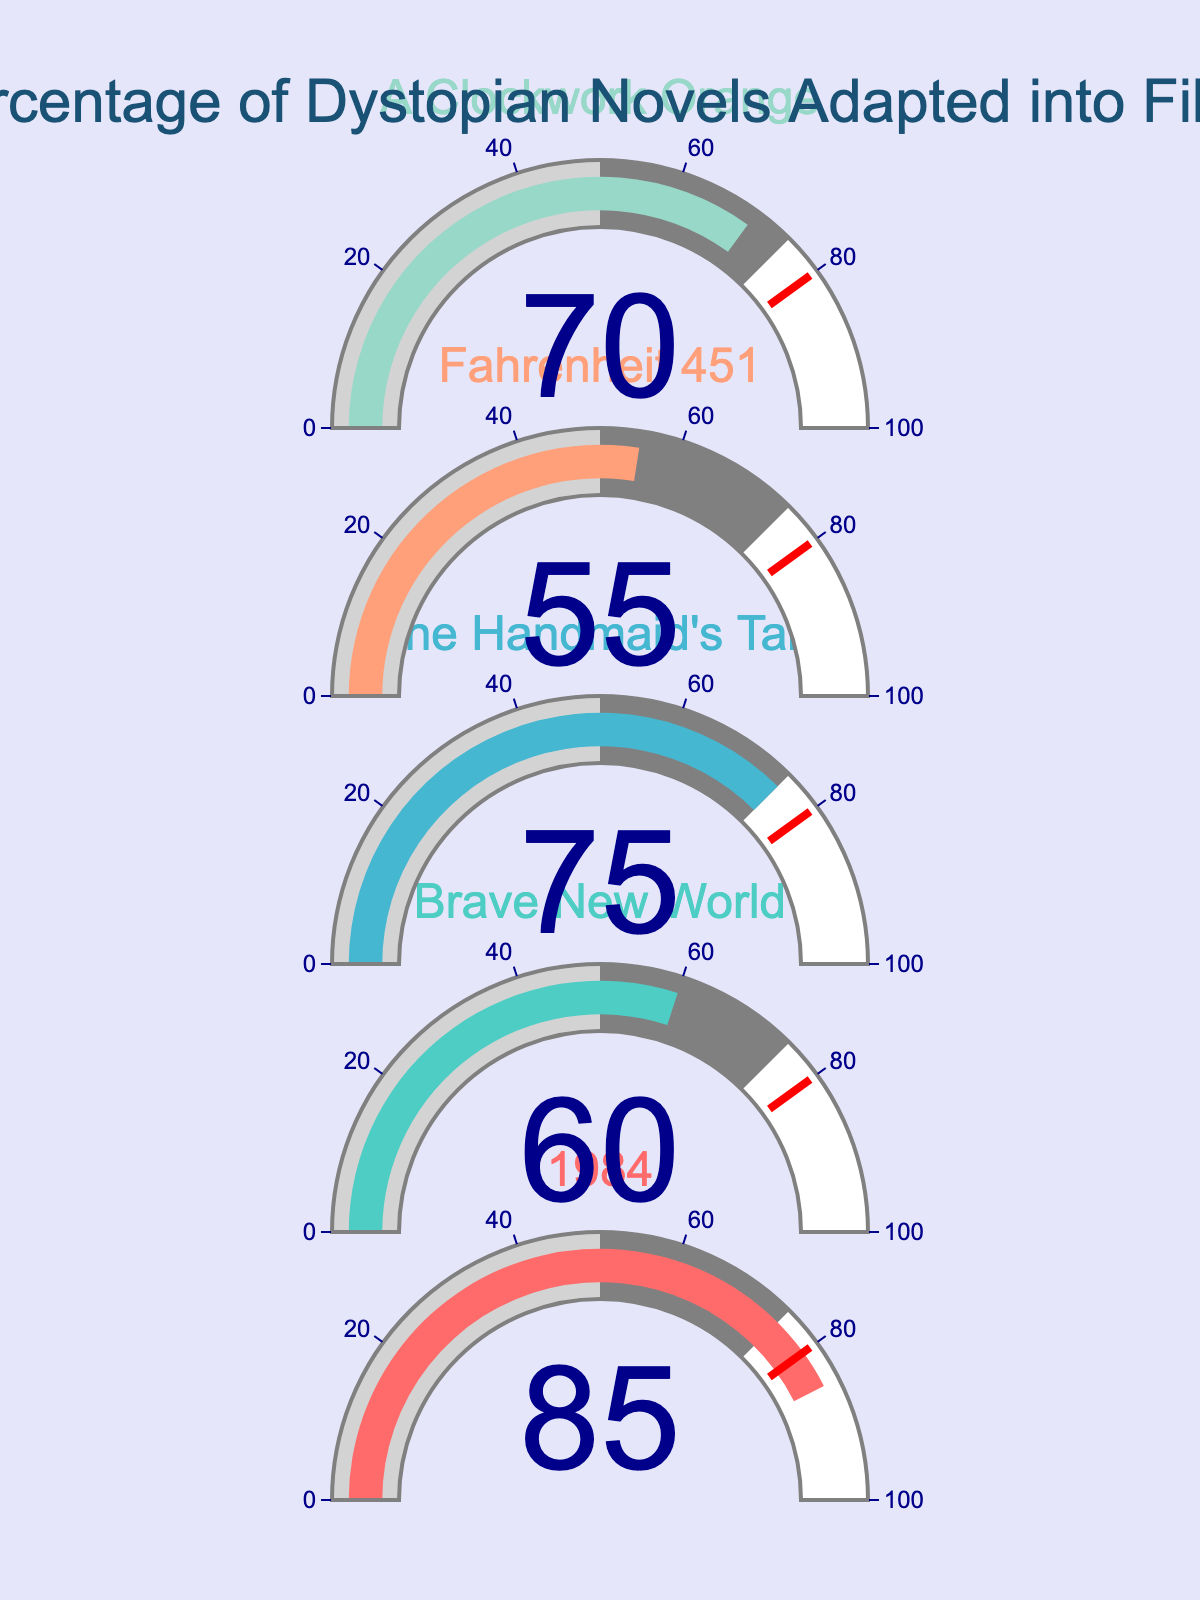Which dystopian novel has the highest adaptation percentage? The gauge chart shows the adaptation percentages for various dystopian novels. By comparing the values shown on the gauges, we see that "1984" has the highest adaptation percentage at 85%.
Answer: 1984 Which dystopian novel has the lowest adaptation percentage? The gauges display the adaptation percentages of different novels. The lowest value on the gauges is 55%, which corresponds to "Fahrenheit 451".
Answer: Fahrenheit 451 What is the average adaptation percentage of all the dystopian novels? To find the average adaptation percentage, add the percentages and divide by the number of novels: (85 + 60 + 75 + 55 + 70) / 5 = 345 / 5 = 69.
Answer: 69 Which two dystopian novels have adaptation percentages closest to each other? Checking the gauges, we see that "Brave New World" has an adaptation percentage of 60%, and "Fahrenheit 451" has an adaptation percentage of 55%. The difference between these two values is the smallest.
Answer: Brave New World and Fahrenheit 451 How much higher is the adaptation percentage of "The Handmaid's Tale" compared to "Fahrenheit 451"? The adaptation percentage for "The Handmaid's Tale" is 75%, and for "Fahrenheit 451" it is 55%. The difference is 75% - 55% = 20%.
Answer: 20% Is the adaptation percentage of "A Clockwork Orange" above or below the average adaptation percentage of all the novels? The average adaptation percentage is 69%. The adaptation percentage for "A Clockwork Orange" is 70%, which is above the average.
Answer: Above What is the difference between the highest and lowest adaptation percentages? The highest adaptation percentage is 85% (1984), and the lowest is 55% (Fahrenheit 451). The difference is 85% - 55% = 30%.
Answer: 30% What percentage of the displayed novels have an adaptation percentage greater than 70%? The novels with adaptation percentages greater than 70% are "1984" (85%) and "The Handmaid's Tale" (75%). That is 2 out of 5 novels, or (2/5)*100 = 40%.
Answer: 40% What is the median adaptation percentage of the dystopian novels? To find the median, we order the adaptation percentages: 55%, 60%, 70%, 75%, 85%. The middle value is 70%.
Answer: 70% Does any novel have an adaptation percentage exactly on the threshold value represented by a red line in the plot? The red threshold line is at 80%, and since none of the gauges show an exact 80%, no novel has an adaptation percentage exactly on this threshold.
Answer: No 